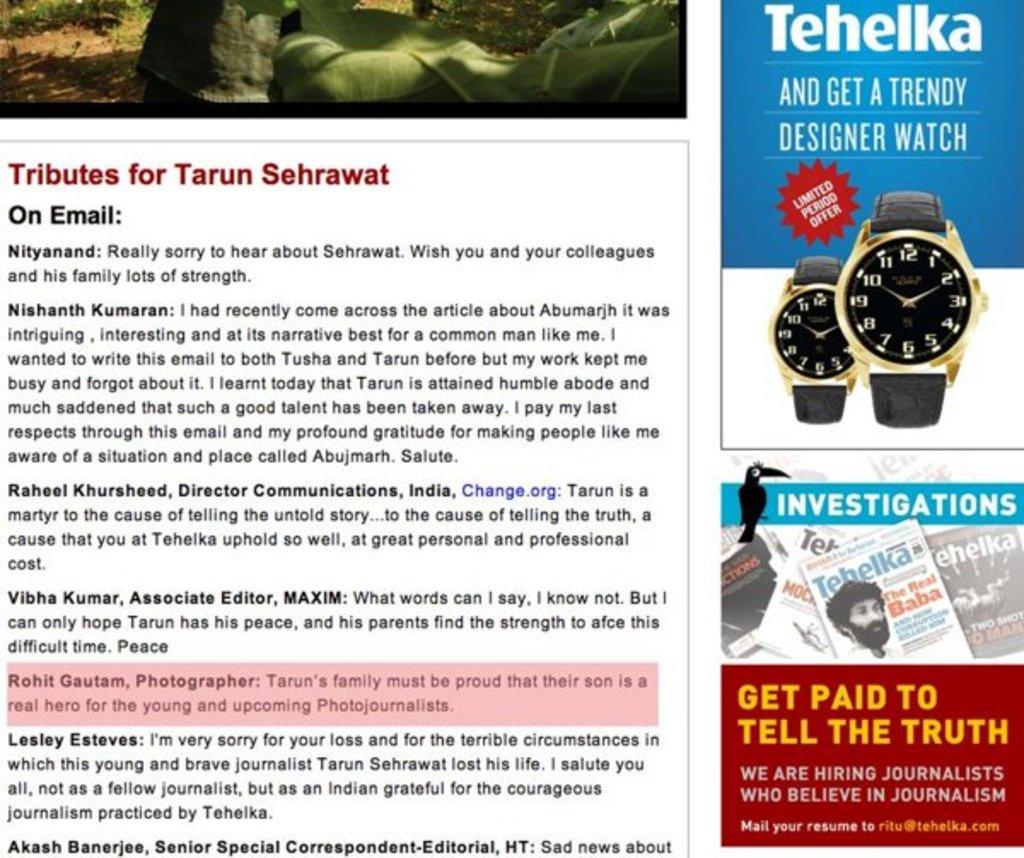What do you get paid to do according to the red advert?
Your response must be concise. To tell the truth. Is tehelka the watch brand shown>?
Offer a terse response. Yes. 